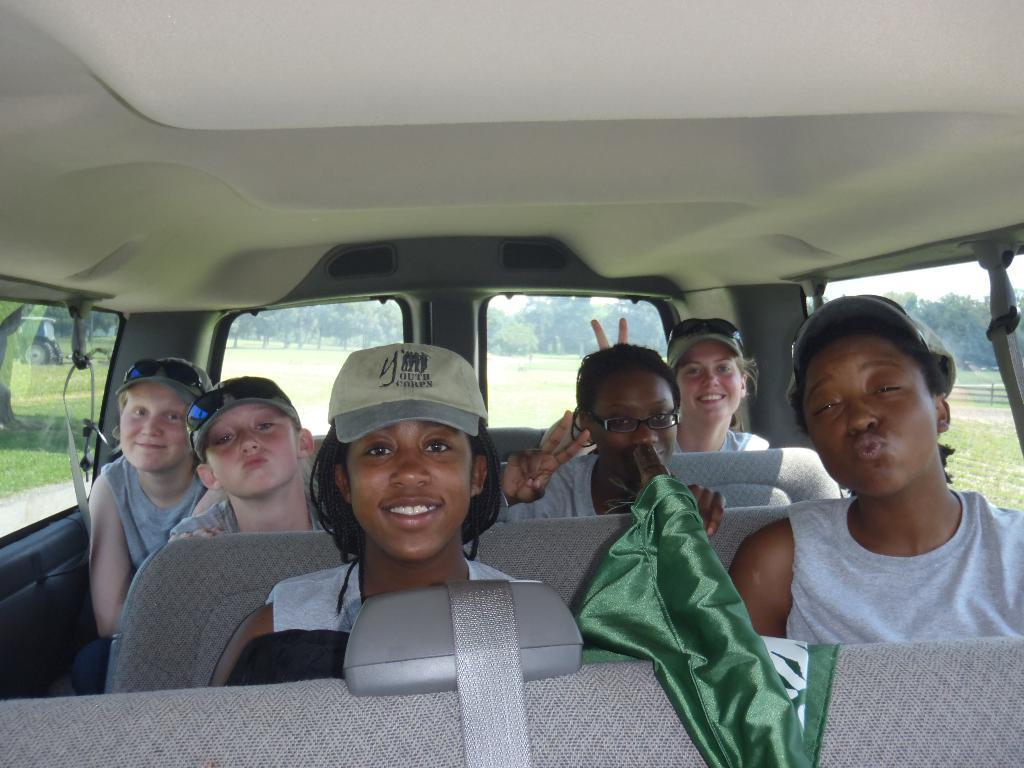How many children are present in the image? There are 6 children in the image. What is the facial expression of the children? All the children are smiling. Where are the children located in the image? The children are in a vehicle. What can be seen in the background of the image? There is grass and trees visible in the background of the image. What type of reaction can be seen on the branch in the image? There is no branch present in the image, so it is not possible to determine any reaction on it. 